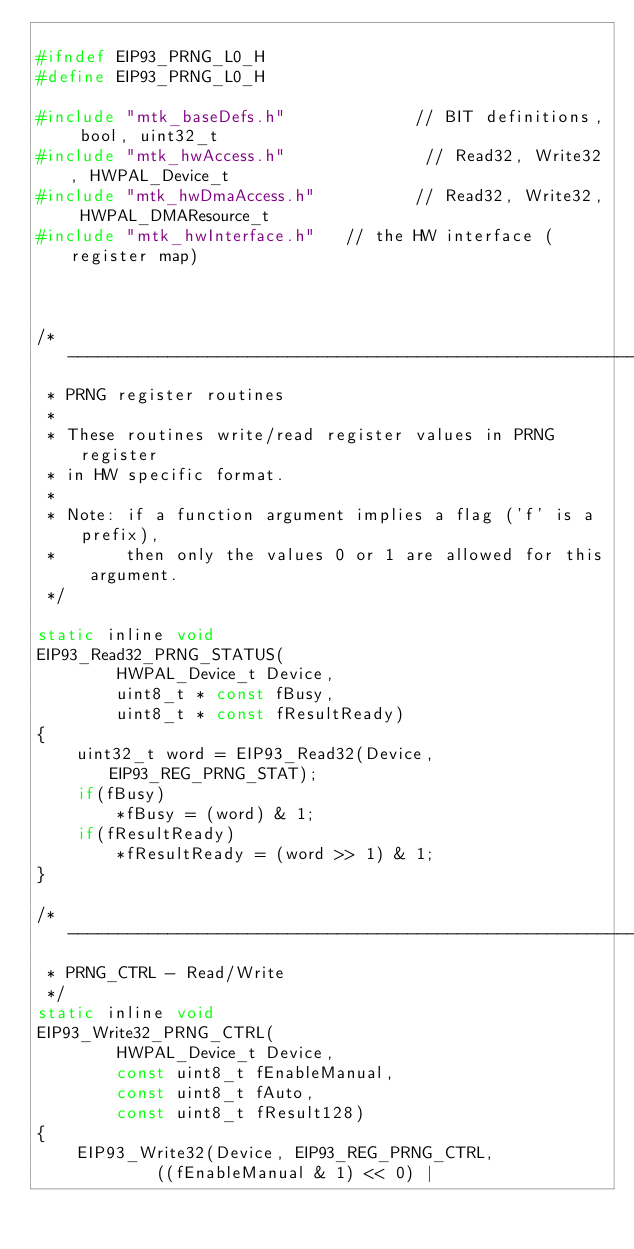<code> <loc_0><loc_0><loc_500><loc_500><_C_>
#ifndef EIP93_PRNG_L0_H
#define EIP93_PRNG_L0_H

#include "mtk_baseDefs.h"             // BIT definitions, bool, uint32_t
#include "mtk_hwAccess.h"              // Read32, Write32, HWPAL_Device_t
#include "mtk_hwDmaAccess.h"          // Read32, Write32, HWPAL_DMAResource_t
#include "mtk_hwInterface.h"   // the HW interface (register map)



/*-----------------------------------------------------------------------------
 * PRNG register routines
 *
 * These routines write/read register values in PRNG register
 * in HW specific format.
 *
 * Note: if a function argument implies a flag ('f' is a prefix),
 *       then only the values 0 or 1 are allowed for this argument.
 */

static inline void
EIP93_Read32_PRNG_STATUS(
        HWPAL_Device_t Device,
        uint8_t * const fBusy,
        uint8_t * const fResultReady)
{
    uint32_t word = EIP93_Read32(Device, EIP93_REG_PRNG_STAT);
    if(fBusy)
        *fBusy = (word) & 1;
    if(fResultReady)
        *fResultReady = (word >> 1) & 1;
}

/*-----------------------------------------------------------------------------
 * PRNG_CTRL - Read/Write
 */
static inline void
EIP93_Write32_PRNG_CTRL(
        HWPAL_Device_t Device,
        const uint8_t fEnableManual,
        const uint8_t fAuto,
        const uint8_t fResult128)
{
    EIP93_Write32(Device, EIP93_REG_PRNG_CTRL,
            ((fEnableManual & 1) << 0) |</code> 